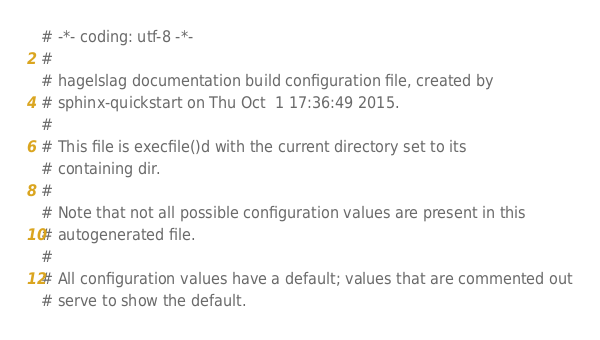<code> <loc_0><loc_0><loc_500><loc_500><_Python_># -*- coding: utf-8 -*-
#
# hagelslag documentation build configuration file, created by
# sphinx-quickstart on Thu Oct  1 17:36:49 2015.
#
# This file is execfile()d with the current directory set to its
# containing dir.
#
# Note that not all possible configuration values are present in this
# autogenerated file.
#
# All configuration values have a default; values that are commented out
# serve to show the default.
</code> 